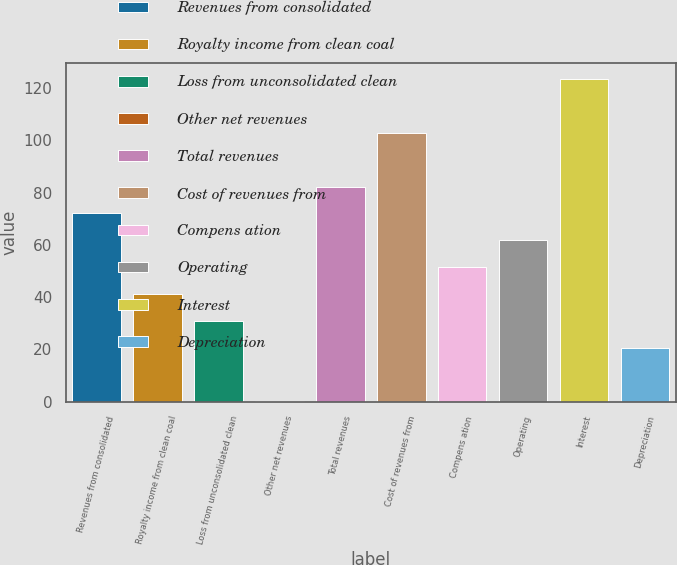Convert chart. <chart><loc_0><loc_0><loc_500><loc_500><bar_chart><fcel>Revenues from consolidated<fcel>Royalty income from clean coal<fcel>Loss from unconsolidated clean<fcel>Other net revenues<fcel>Total revenues<fcel>Cost of revenues from<fcel>Compens ation<fcel>Operating<fcel>Interest<fcel>Depreciation<nl><fcel>72.02<fcel>41.24<fcel>30.98<fcel>0.2<fcel>82.28<fcel>102.8<fcel>51.5<fcel>61.76<fcel>123.32<fcel>20.72<nl></chart> 